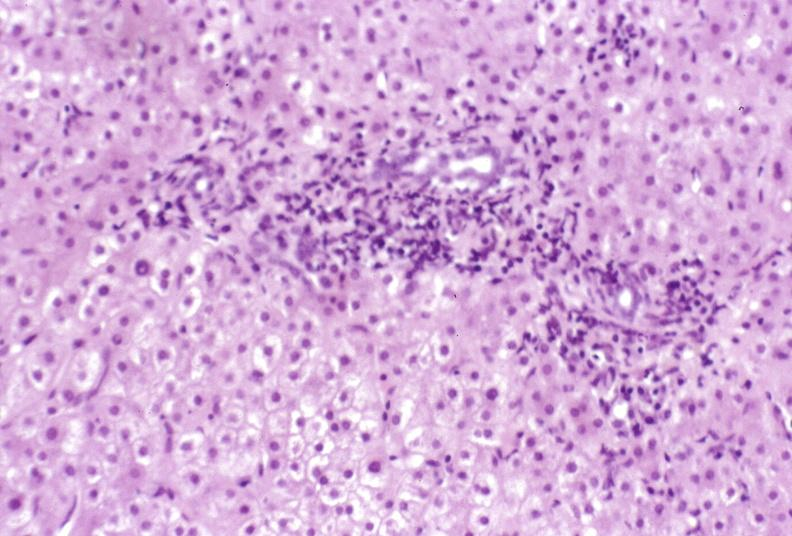s metastatic malignant melanoma present?
Answer the question using a single word or phrase. No 